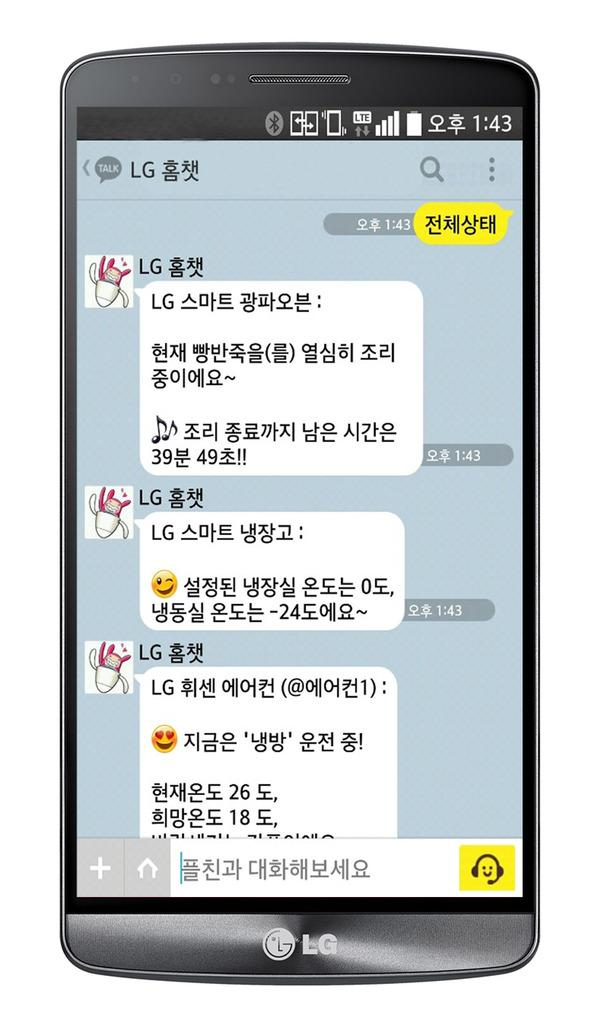Provide a one-sentence caption for the provided image. A phone with Korean characters displaying a time of 1:43. 